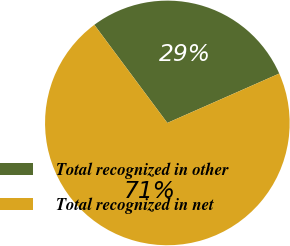Convert chart to OTSL. <chart><loc_0><loc_0><loc_500><loc_500><pie_chart><fcel>Total recognized in other<fcel>Total recognized in net<nl><fcel>28.57%<fcel>71.43%<nl></chart> 